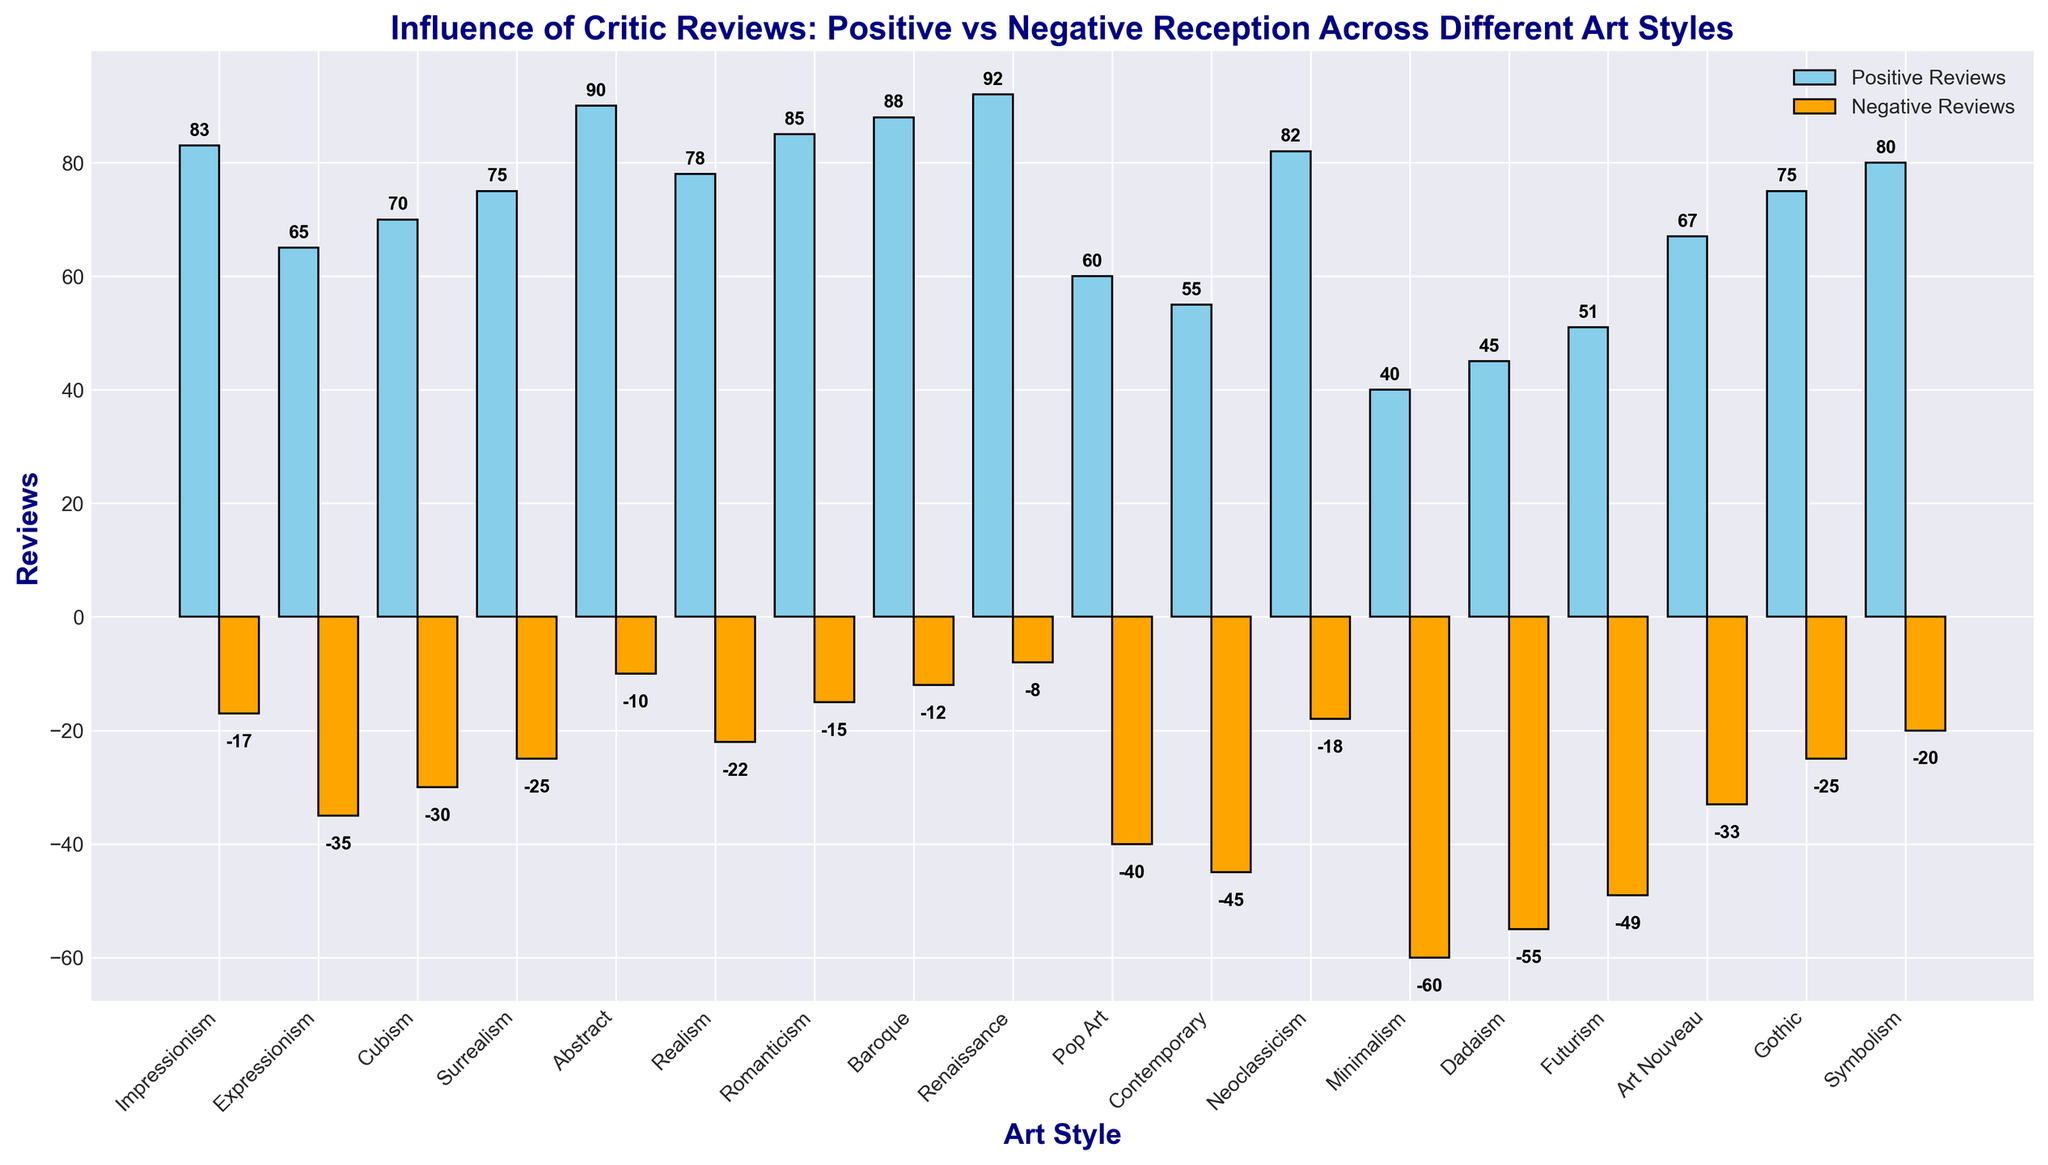What's the art style with the highest number of positive reviews? Look at the height of the blue bars and identify which one is the tallest. The tallest bar represents the highest number of positive reviews.
Answer: Renaissance Which art style received the most negative reviews? Look at the orange bars and identify which one extends the farthest downwards (has the lowest value). This bar represents the most negative reviews.
Answer: Minimalism What is the difference between positive and negative reviews for Pop Art? Find the values for positive and negative reviews of Pop Art: positive is 60 and negative is -40. Calculate the difference: 60 - 40 = 100.
Answer: 100 Which art styles have received more positive reviews than negative reviews? Identify all art styles where the blue bar (positive reviews) is taller than the orange bar (negative reviews). These styles include all but Minimalism, Dadaism, Futurism, and Contemporary.
Answer: Impressionism, Expressionism, Cubism, Surrealism, Abstract, Realism, Romanticism, Baroque, Renaissance, Pop Art, Neoclassicism, Art Nouveau, Gothic, Symbolism Is there an art style with an equal number of positive and negative reviews? Check if any blue and orange bars are of equal height. There are no such bars, meaning no art style has an equal number of positive and negative reviews.
Answer: No What is the average number of positive reviews across all art styles? Sum all positive review values and divide by the number of art styles: (83+65+70+75+90+78+85+88+92+60+55+82+40+45+51+67+75+80)/18 = 73.
Answer: 73 Which art styles have fewer than 50 positive reviews? Look for blue bars representing positive reviews under 50. Identify Minimalism, Dadaism, and Contemporary.
Answer: Minimalism, Dadaism, Contemporary What is the most frequent range (in terms of numerical value) for negative reviews among the art styles? Look at the values of the orange bars and identify the most common range. Most values seem to be between -10 and -35.
Answer: -10 to -35 What is the sum of positive reviews for Impressionism and Romanticism? Add the positive reviews for Impressionism (83) and Romanticism (85): 83 + 85 = 168.
Answer: 168 Do Realism and Gothic receive the same number of positive reviews? Compare the height of the blue bars for Realism and Gothic. Both bars reach the value of 75.
Answer: Yes 